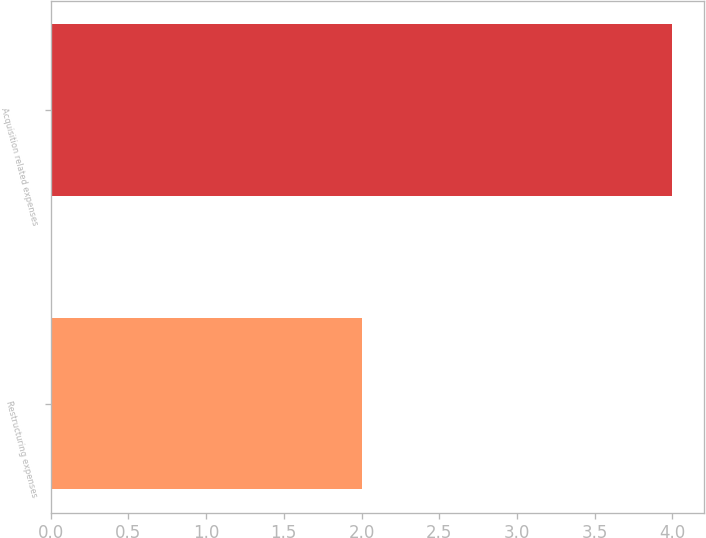<chart> <loc_0><loc_0><loc_500><loc_500><bar_chart><fcel>Restructuring expenses<fcel>Acquisition related expenses<nl><fcel>2<fcel>4<nl></chart> 